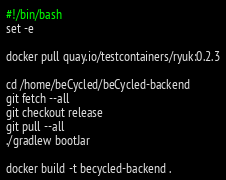<code> <loc_0><loc_0><loc_500><loc_500><_Bash_>#!/bin/bash
set -e

docker pull quay.io/testcontainers/ryuk:0.2.3

cd /home/beCycled/beCycled-backend
git fetch --all
git checkout release
git pull --all
./gradlew bootJar

docker build -t becycled-backend .
</code> 